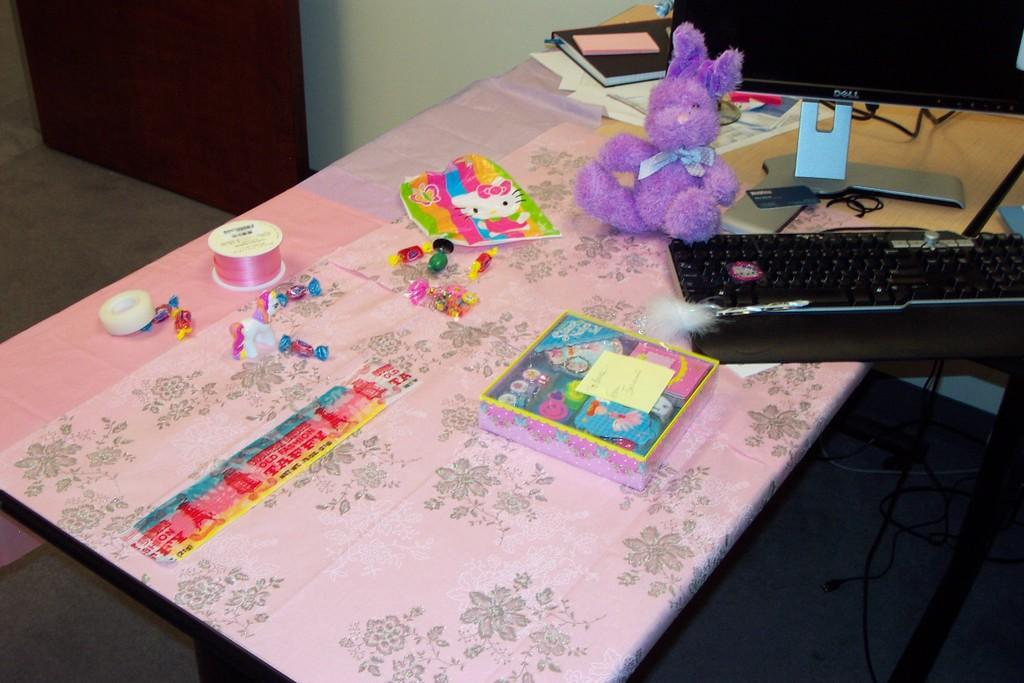What type of objects can be seen in the image? There are toys, a soft toy, a keyboard, a monitor, papers, and a book on the table in the image. Can you describe the soft toy in the image? The soft toy is a plush toy, possibly an animal or character. What is the purpose of the keyboard and monitor in the image? The keyboard and monitor suggest that there is a computer or workstation in the image. What might the papers and book be used for? The papers and book might be used for studying, writing, or taking notes. What type of wine is being served in the image? There is no wine present in the image; it features toys, a soft toy, a keyboard, a monitor, papers, and a book on the table. How many children are visible in the image? There are no children visible in the image; it features toys, a soft toy, a keyboard, a monitor, papers, and a book on the table. 